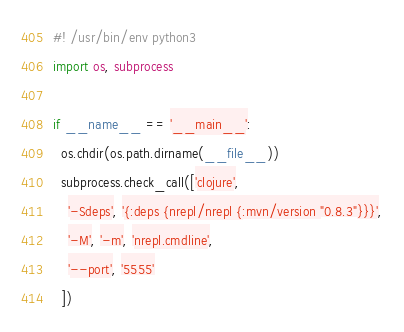Convert code to text. <code><loc_0><loc_0><loc_500><loc_500><_Python_>#! /usr/bin/env python3
import os, subprocess

if __name__ == '__main__':
  os.chdir(os.path.dirname(__file__))
  subprocess.check_call(['clojure',
    '-Sdeps', '{:deps {nrepl/nrepl {:mvn/version "0.8.3"}}}',
    '-M', '-m', 'nrepl.cmdline',
    '--port', '5555'
  ])
</code> 